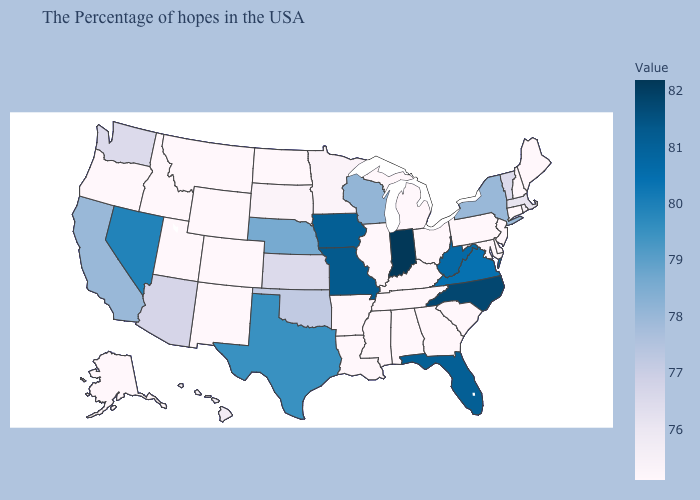Among the states that border Ohio , does Michigan have the lowest value?
Give a very brief answer. Yes. Is the legend a continuous bar?
Concise answer only. Yes. Does Oklahoma have the highest value in the USA?
Write a very short answer. No. Which states hav the highest value in the South?
Short answer required. North Carolina. Which states hav the highest value in the West?
Write a very short answer. Nevada. Which states hav the highest value in the South?
Give a very brief answer. North Carolina. Does Georgia have the lowest value in the USA?
Short answer required. Yes. Which states have the lowest value in the MidWest?
Answer briefly. Ohio, Michigan, Illinois, North Dakota. 